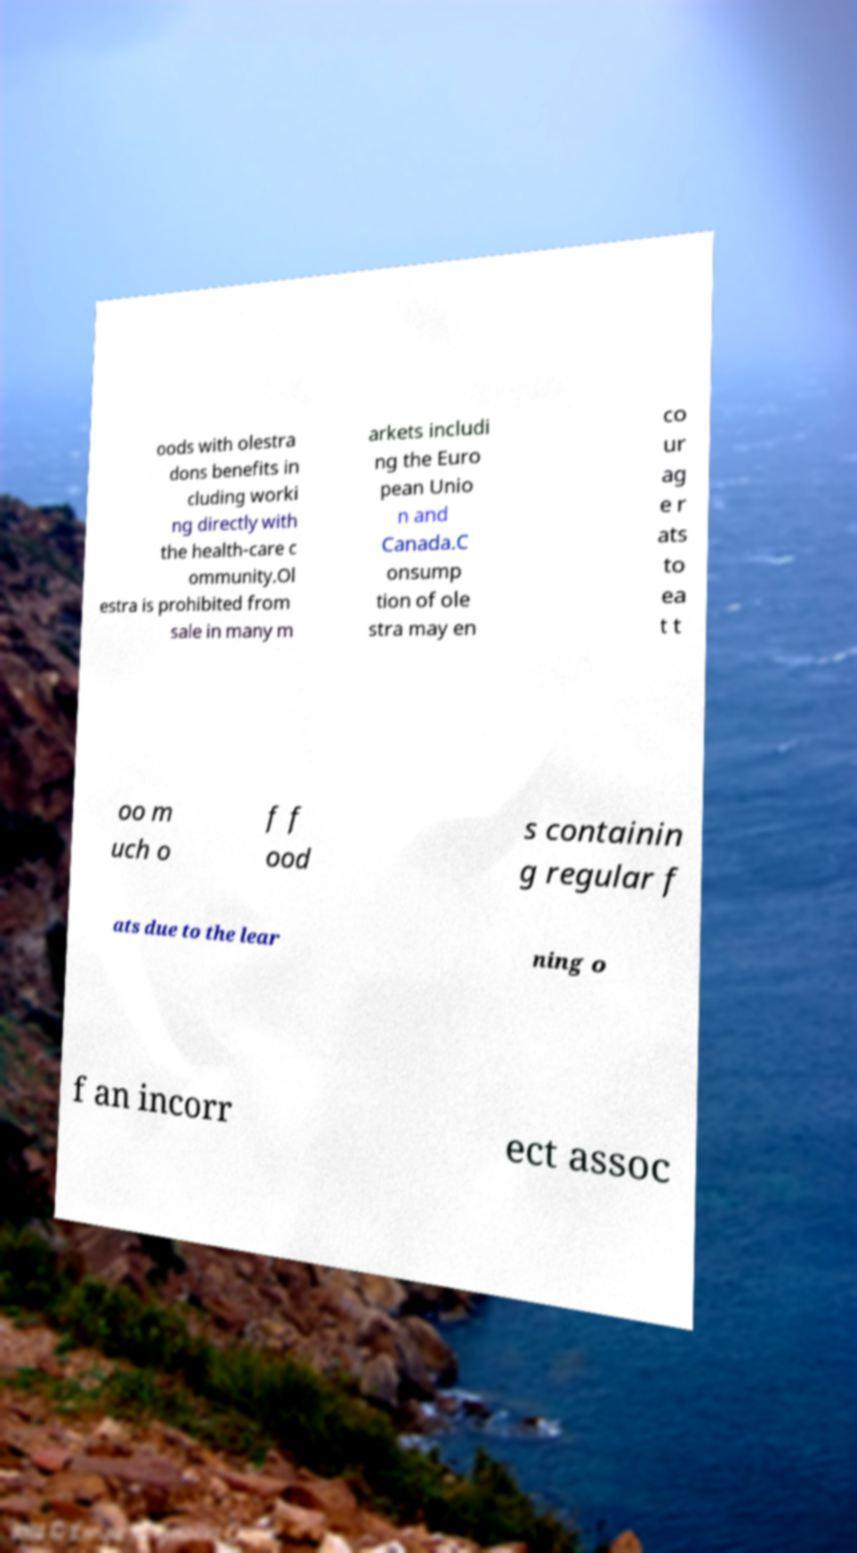Can you read and provide the text displayed in the image?This photo seems to have some interesting text. Can you extract and type it out for me? oods with olestra dons benefits in cluding worki ng directly with the health-care c ommunity.Ol estra is prohibited from sale in many m arkets includi ng the Euro pean Unio n and Canada.C onsump tion of ole stra may en co ur ag e r ats to ea t t oo m uch o f f ood s containin g regular f ats due to the lear ning o f an incorr ect assoc 